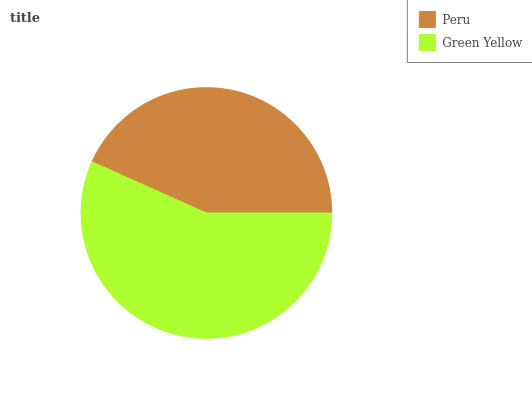Is Peru the minimum?
Answer yes or no. Yes. Is Green Yellow the maximum?
Answer yes or no. Yes. Is Green Yellow the minimum?
Answer yes or no. No. Is Green Yellow greater than Peru?
Answer yes or no. Yes. Is Peru less than Green Yellow?
Answer yes or no. Yes. Is Peru greater than Green Yellow?
Answer yes or no. No. Is Green Yellow less than Peru?
Answer yes or no. No. Is Green Yellow the high median?
Answer yes or no. Yes. Is Peru the low median?
Answer yes or no. Yes. Is Peru the high median?
Answer yes or no. No. Is Green Yellow the low median?
Answer yes or no. No. 